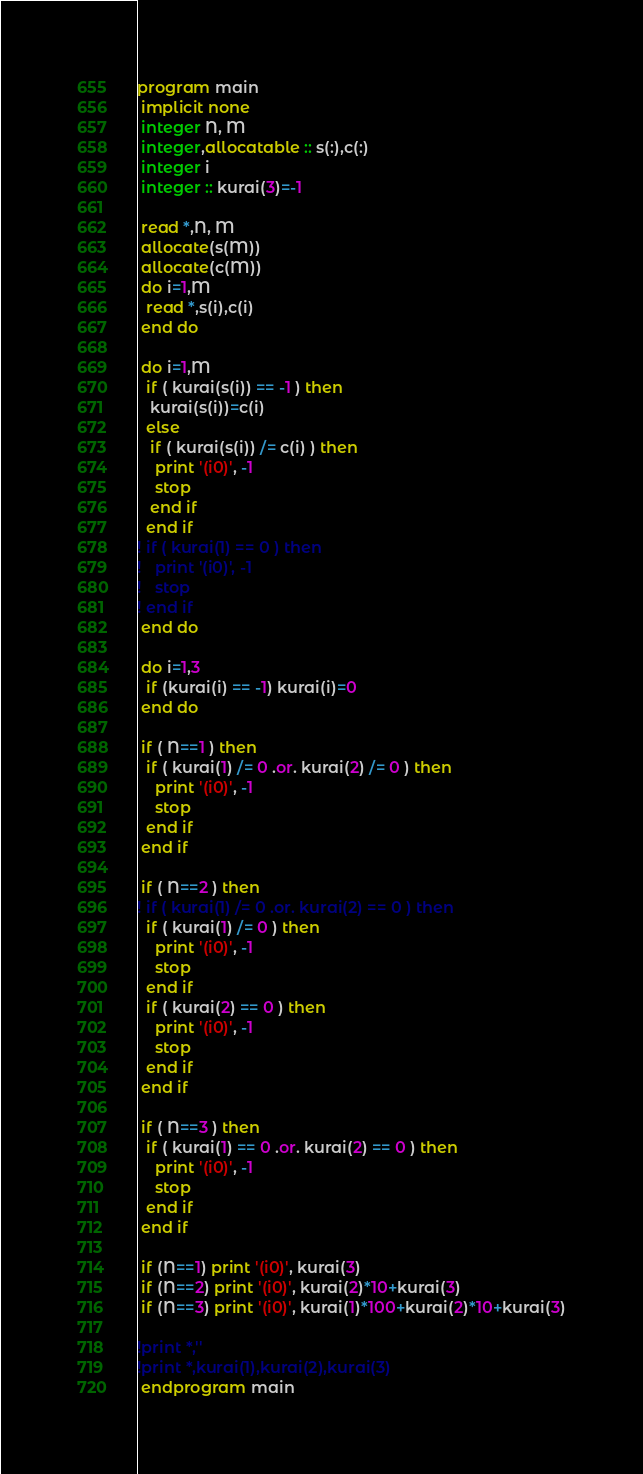Convert code to text. <code><loc_0><loc_0><loc_500><loc_500><_FORTRAN_>program main
 implicit none
 integer N, M
 integer,allocatable :: s(:),c(:)
 integer i
 integer :: kurai(3)=-1

 read *,N, M
 allocate(s(M))
 allocate(c(M))
 do i=1,M
  read *,s(i),c(i)
 end do

 do i=1,M
  if ( kurai(s(i)) == -1 ) then
   kurai(s(i))=c(i)
  else
   if ( kurai(s(i)) /= c(i) ) then
    print '(i0)', -1
    stop
   end if
  end if
! if ( kurai(1) == 0 ) then
!   print '(i0)', -1
!   stop
! end if
 end do

 do i=1,3
  if (kurai(i) == -1) kurai(i)=0
 end do

 if ( N==1 ) then
  if ( kurai(1) /= 0 .or. kurai(2) /= 0 ) then
    print '(i0)', -1
    stop
  end if
 end if 

 if ( N==2 ) then
! if ( kurai(1) /= 0 .or. kurai(2) == 0 ) then
  if ( kurai(1) /= 0 ) then
    print '(i0)', -1
    stop
  end if
  if ( kurai(2) == 0 ) then
    print '(i0)', -1
    stop
  end if
 end if

 if ( N==3 ) then
  if ( kurai(1) == 0 .or. kurai(2) == 0 ) then
    print '(i0)', -1
    stop
  end if
 end if

 if (N==1) print '(i0)', kurai(3)
 if (N==2) print '(i0)', kurai(2)*10+kurai(3)
 if (N==3) print '(i0)', kurai(1)*100+kurai(2)*10+kurai(3)

!print *,''
!print *,kurai(1),kurai(2),kurai(3)
 endprogram main







</code> 